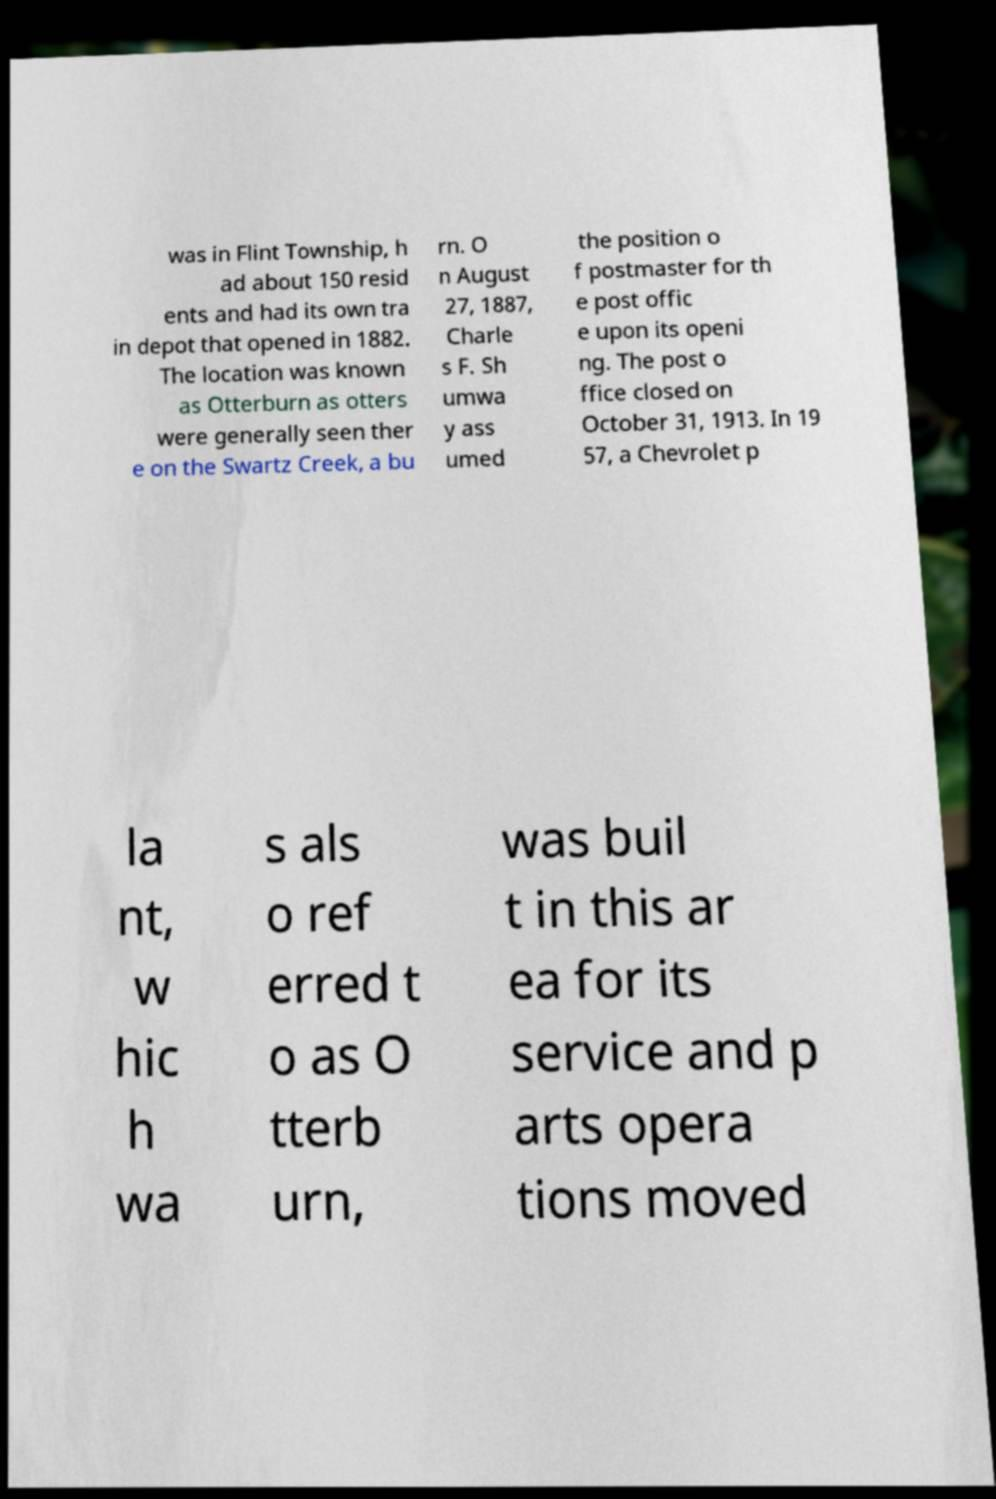Could you extract and type out the text from this image? was in Flint Township, h ad about 150 resid ents and had its own tra in depot that opened in 1882. The location was known as Otterburn as otters were generally seen ther e on the Swartz Creek, a bu rn. O n August 27, 1887, Charle s F. Sh umwa y ass umed the position o f postmaster for th e post offic e upon its openi ng. The post o ffice closed on October 31, 1913. In 19 57, a Chevrolet p la nt, w hic h wa s als o ref erred t o as O tterb urn, was buil t in this ar ea for its service and p arts opera tions moved 